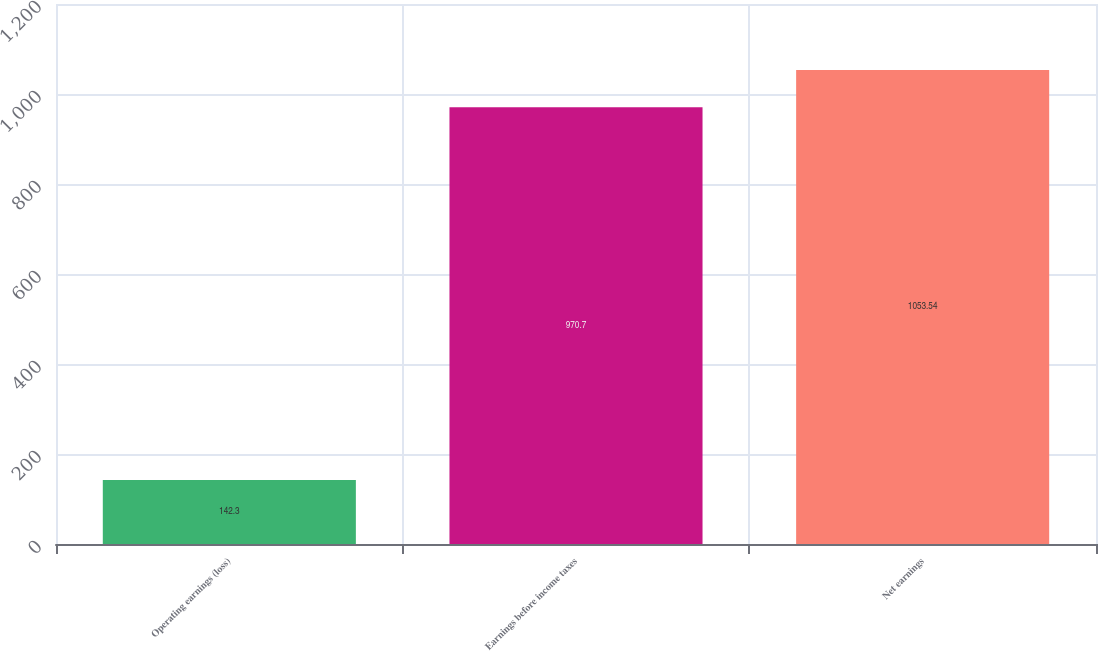<chart> <loc_0><loc_0><loc_500><loc_500><bar_chart><fcel>Operating earnings (loss)<fcel>Earnings before income taxes<fcel>Net earnings<nl><fcel>142.3<fcel>970.7<fcel>1053.54<nl></chart> 